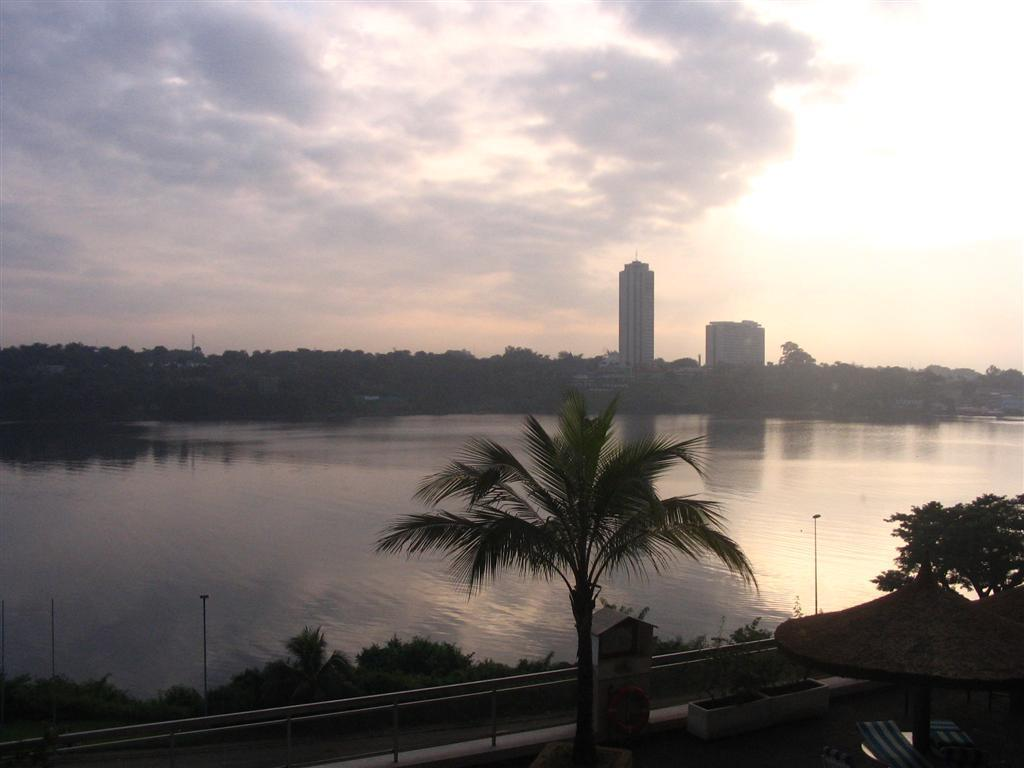What is the primary element visible in the image? There is water in the image. What is located on the sides of the water? There are plants, trees, and railings on the sides of the water. What type of structure can be seen in the image? There is a tent with benches in the image. What can be seen in the background of the image? There are trees, buildings, and the sky visible in the background of the image. What type of discovery was made on the canvas in the image? There is no canvas or discovery present in the image; it features water, plants, trees, railings, a tent with benches, and a background with trees, buildings, and the sky. There is no mention of a canvas or any discovery in the image. 